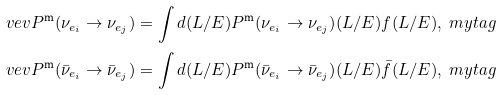<formula> <loc_0><loc_0><loc_500><loc_500>\ v e v { P ^ { \text {m} } ( \nu _ { e _ { i } } \rightarrow \nu _ { e _ { j } } ) } & = \int d ( L / E ) P ^ { \text {m} } { ( \nu _ { e _ { i } } \rightarrow \nu _ { e _ { j } } ) } ( L / E ) f ( L / E ) , \ m y t a g \\ \ v e v { P ^ { \text {m} } ( \bar { \nu } _ { e _ { i } } \rightarrow \bar { \nu } _ { e _ { j } } ) } & = \int d ( L / E ) P ^ { \text {m} } { ( \bar { \nu } _ { e _ { i } } \rightarrow \bar { \nu } _ { e _ { j } } ) } ( L / E ) \bar { f } ( L / E ) , \ m y t a g</formula> 